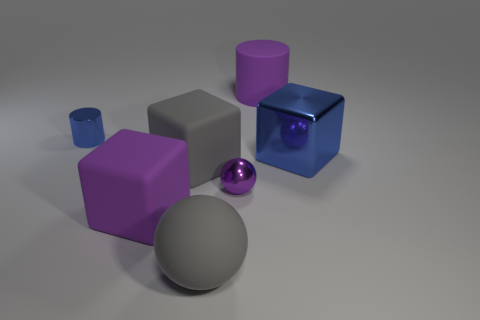Add 3 big matte objects. How many objects exist? 10 Subtract all cylinders. How many objects are left? 5 Add 4 small metallic cylinders. How many small metallic cylinders are left? 5 Add 5 tiny purple balls. How many tiny purple balls exist? 6 Subtract 0 brown blocks. How many objects are left? 7 Subtract all purple metal balls. Subtract all large cubes. How many objects are left? 3 